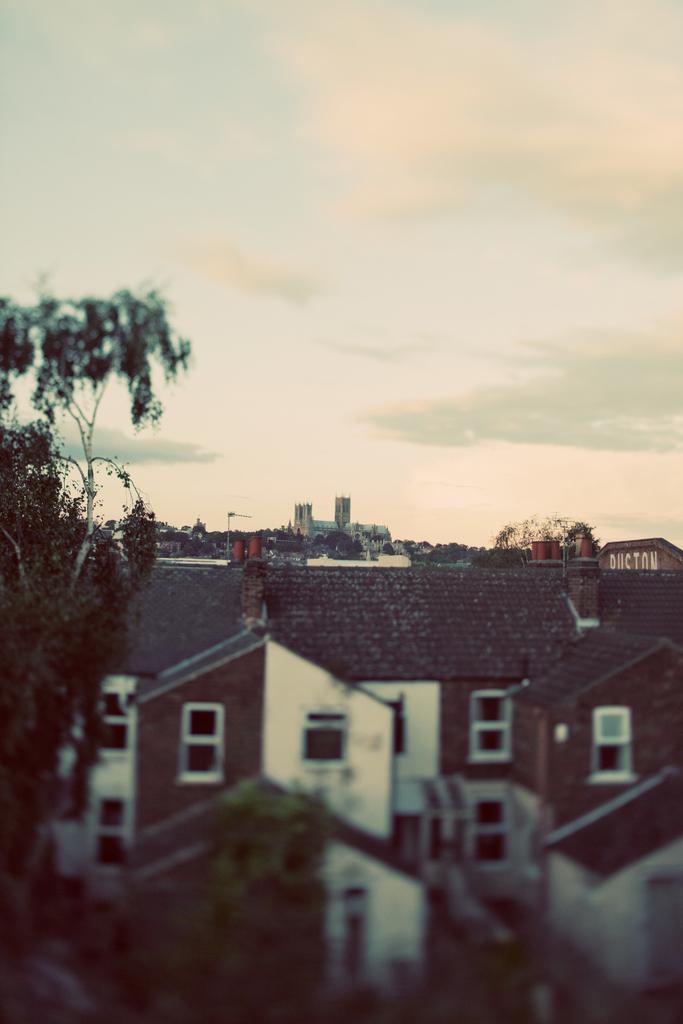Describe this image in one or two sentences. In this image we can see a group of buildings and trees. At the bottom the image is blurred. At the top we can see the sky. 